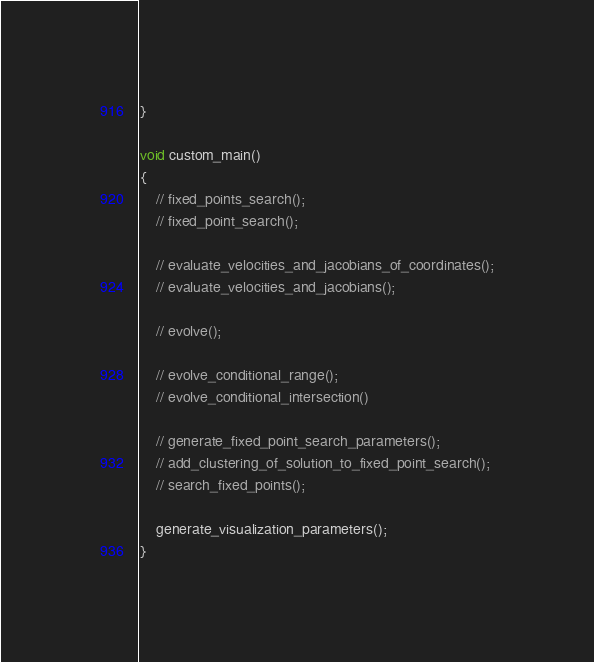Convert code to text. <code><loc_0><loc_0><loc_500><loc_500><_Cuda_>}

void custom_main()
{
    // fixed_points_search();
    // fixed_point_search();

    // evaluate_velocities_and_jacobians_of_coordinates();
    // evaluate_velocities_and_jacobians();

    // evolve();

    // evolve_conditional_range();
    // evolve_conditional_intersection()

    // generate_fixed_point_search_parameters();
    // add_clustering_of_solution_to_fixed_point_search();
    // search_fixed_points();

    generate_visualization_parameters();
}
</code> 